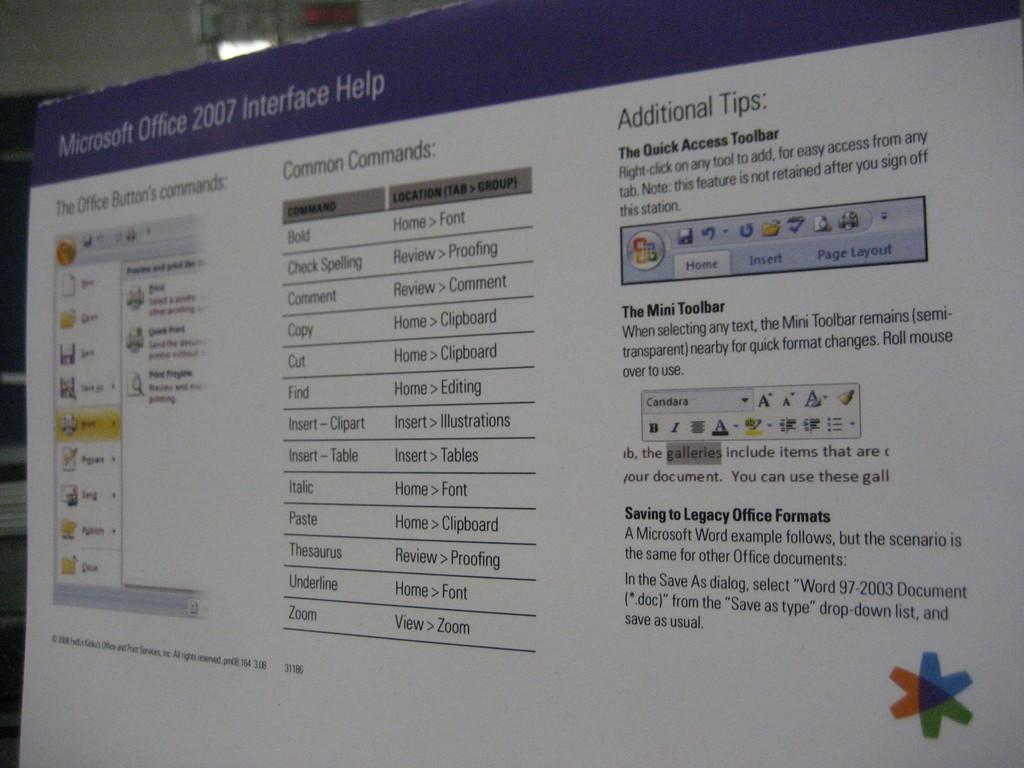<image>
Present a compact description of the photo's key features. A poster about Microsoft Office 2007 Interface Help. 